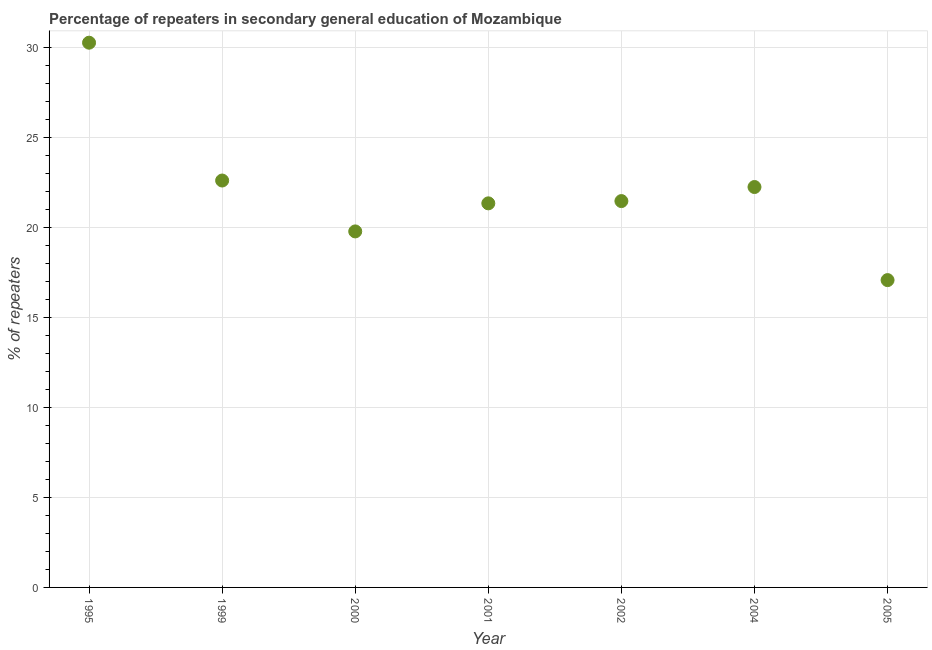What is the percentage of repeaters in 2001?
Make the answer very short. 21.36. Across all years, what is the maximum percentage of repeaters?
Your answer should be compact. 30.29. Across all years, what is the minimum percentage of repeaters?
Provide a short and direct response. 17.09. What is the sum of the percentage of repeaters?
Your response must be concise. 154.9. What is the difference between the percentage of repeaters in 1995 and 2001?
Your answer should be very brief. 8.93. What is the average percentage of repeaters per year?
Your response must be concise. 22.13. What is the median percentage of repeaters?
Your response must be concise. 21.48. Do a majority of the years between 2000 and 2001 (inclusive) have percentage of repeaters greater than 13 %?
Your response must be concise. Yes. What is the ratio of the percentage of repeaters in 2001 to that in 2002?
Provide a succinct answer. 0.99. Is the percentage of repeaters in 1999 less than that in 2004?
Provide a succinct answer. No. Is the difference between the percentage of repeaters in 1995 and 2004 greater than the difference between any two years?
Provide a succinct answer. No. What is the difference between the highest and the second highest percentage of repeaters?
Keep it short and to the point. 7.66. Is the sum of the percentage of repeaters in 1995 and 2005 greater than the maximum percentage of repeaters across all years?
Your response must be concise. Yes. What is the difference between the highest and the lowest percentage of repeaters?
Give a very brief answer. 13.2. In how many years, is the percentage of repeaters greater than the average percentage of repeaters taken over all years?
Ensure brevity in your answer.  3. What is the difference between two consecutive major ticks on the Y-axis?
Your answer should be compact. 5. What is the title of the graph?
Offer a terse response. Percentage of repeaters in secondary general education of Mozambique. What is the label or title of the X-axis?
Your answer should be very brief. Year. What is the label or title of the Y-axis?
Give a very brief answer. % of repeaters. What is the % of repeaters in 1995?
Offer a very short reply. 30.29. What is the % of repeaters in 1999?
Give a very brief answer. 22.62. What is the % of repeaters in 2000?
Your answer should be very brief. 19.8. What is the % of repeaters in 2001?
Provide a succinct answer. 21.36. What is the % of repeaters in 2002?
Your response must be concise. 21.48. What is the % of repeaters in 2004?
Provide a short and direct response. 22.26. What is the % of repeaters in 2005?
Give a very brief answer. 17.09. What is the difference between the % of repeaters in 1995 and 1999?
Offer a very short reply. 7.66. What is the difference between the % of repeaters in 1995 and 2000?
Your answer should be very brief. 10.49. What is the difference between the % of repeaters in 1995 and 2001?
Your answer should be compact. 8.93. What is the difference between the % of repeaters in 1995 and 2002?
Keep it short and to the point. 8.81. What is the difference between the % of repeaters in 1995 and 2004?
Your answer should be compact. 8.02. What is the difference between the % of repeaters in 1995 and 2005?
Ensure brevity in your answer.  13.2. What is the difference between the % of repeaters in 1999 and 2000?
Your answer should be compact. 2.83. What is the difference between the % of repeaters in 1999 and 2001?
Keep it short and to the point. 1.27. What is the difference between the % of repeaters in 1999 and 2002?
Make the answer very short. 1.14. What is the difference between the % of repeaters in 1999 and 2004?
Provide a succinct answer. 0.36. What is the difference between the % of repeaters in 1999 and 2005?
Ensure brevity in your answer.  5.54. What is the difference between the % of repeaters in 2000 and 2001?
Provide a succinct answer. -1.56. What is the difference between the % of repeaters in 2000 and 2002?
Offer a very short reply. -1.69. What is the difference between the % of repeaters in 2000 and 2004?
Your answer should be very brief. -2.47. What is the difference between the % of repeaters in 2000 and 2005?
Provide a succinct answer. 2.71. What is the difference between the % of repeaters in 2001 and 2002?
Your answer should be compact. -0.13. What is the difference between the % of repeaters in 2001 and 2004?
Make the answer very short. -0.91. What is the difference between the % of repeaters in 2001 and 2005?
Keep it short and to the point. 4.27. What is the difference between the % of repeaters in 2002 and 2004?
Ensure brevity in your answer.  -0.78. What is the difference between the % of repeaters in 2002 and 2005?
Keep it short and to the point. 4.39. What is the difference between the % of repeaters in 2004 and 2005?
Provide a short and direct response. 5.18. What is the ratio of the % of repeaters in 1995 to that in 1999?
Provide a short and direct response. 1.34. What is the ratio of the % of repeaters in 1995 to that in 2000?
Make the answer very short. 1.53. What is the ratio of the % of repeaters in 1995 to that in 2001?
Give a very brief answer. 1.42. What is the ratio of the % of repeaters in 1995 to that in 2002?
Ensure brevity in your answer.  1.41. What is the ratio of the % of repeaters in 1995 to that in 2004?
Offer a terse response. 1.36. What is the ratio of the % of repeaters in 1995 to that in 2005?
Make the answer very short. 1.77. What is the ratio of the % of repeaters in 1999 to that in 2000?
Keep it short and to the point. 1.14. What is the ratio of the % of repeaters in 1999 to that in 2001?
Make the answer very short. 1.06. What is the ratio of the % of repeaters in 1999 to that in 2002?
Offer a very short reply. 1.05. What is the ratio of the % of repeaters in 1999 to that in 2005?
Make the answer very short. 1.32. What is the ratio of the % of repeaters in 2000 to that in 2001?
Your answer should be very brief. 0.93. What is the ratio of the % of repeaters in 2000 to that in 2002?
Your answer should be compact. 0.92. What is the ratio of the % of repeaters in 2000 to that in 2004?
Your response must be concise. 0.89. What is the ratio of the % of repeaters in 2000 to that in 2005?
Offer a terse response. 1.16. What is the ratio of the % of repeaters in 2001 to that in 2002?
Provide a succinct answer. 0.99. What is the ratio of the % of repeaters in 2002 to that in 2005?
Keep it short and to the point. 1.26. What is the ratio of the % of repeaters in 2004 to that in 2005?
Provide a succinct answer. 1.3. 